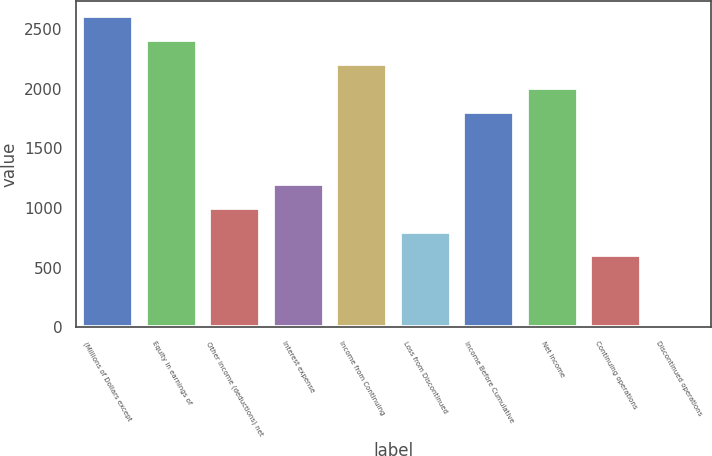Convert chart. <chart><loc_0><loc_0><loc_500><loc_500><bar_chart><fcel>(Millions of Dollars except<fcel>Equity in earnings of<fcel>Other income (deductions) net<fcel>Interest expense<fcel>Income from Continuing<fcel>Loss from Discontinued<fcel>Income Before Cumulative<fcel>Net Income<fcel>Continuing operations<fcel>Discontinued operations<nl><fcel>2606.53<fcel>2406.03<fcel>1002.53<fcel>1203.03<fcel>2205.53<fcel>802.04<fcel>1804.53<fcel>2005.03<fcel>601.55<fcel>0.05<nl></chart> 